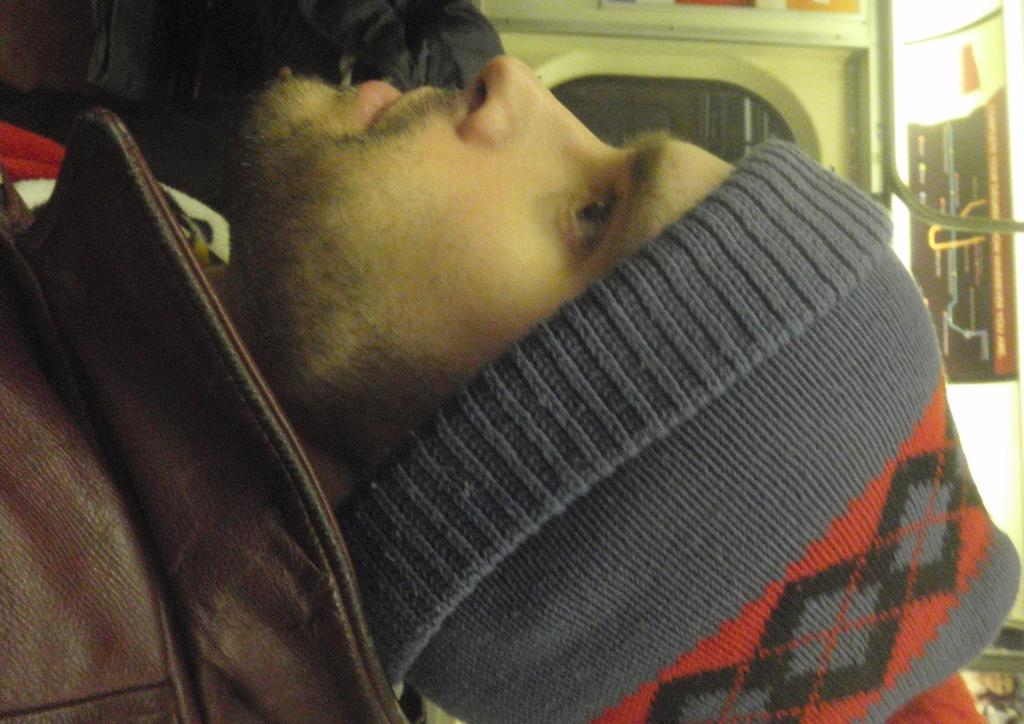What is the main subject of the image? The main subject of the image is a man. What is the man wearing on his head? The man is wearing a cap. What type of clothing is the man wearing on his upper body? The man is wearing a jacket. Can you describe the setting of the image? The man may be inside a vehicle, and there is a window in the background of the image. What can be seen on the right side of the image? There is a rod on the right side of the image. What type of silverware is visible in the image? There is no silverware present in the image. How many geese are flying in the background of the image? There are no geese present in the image. 